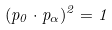Convert formula to latex. <formula><loc_0><loc_0><loc_500><loc_500>( p _ { 0 } \cdot p _ { \alpha } ) ^ { 2 } = 1</formula> 